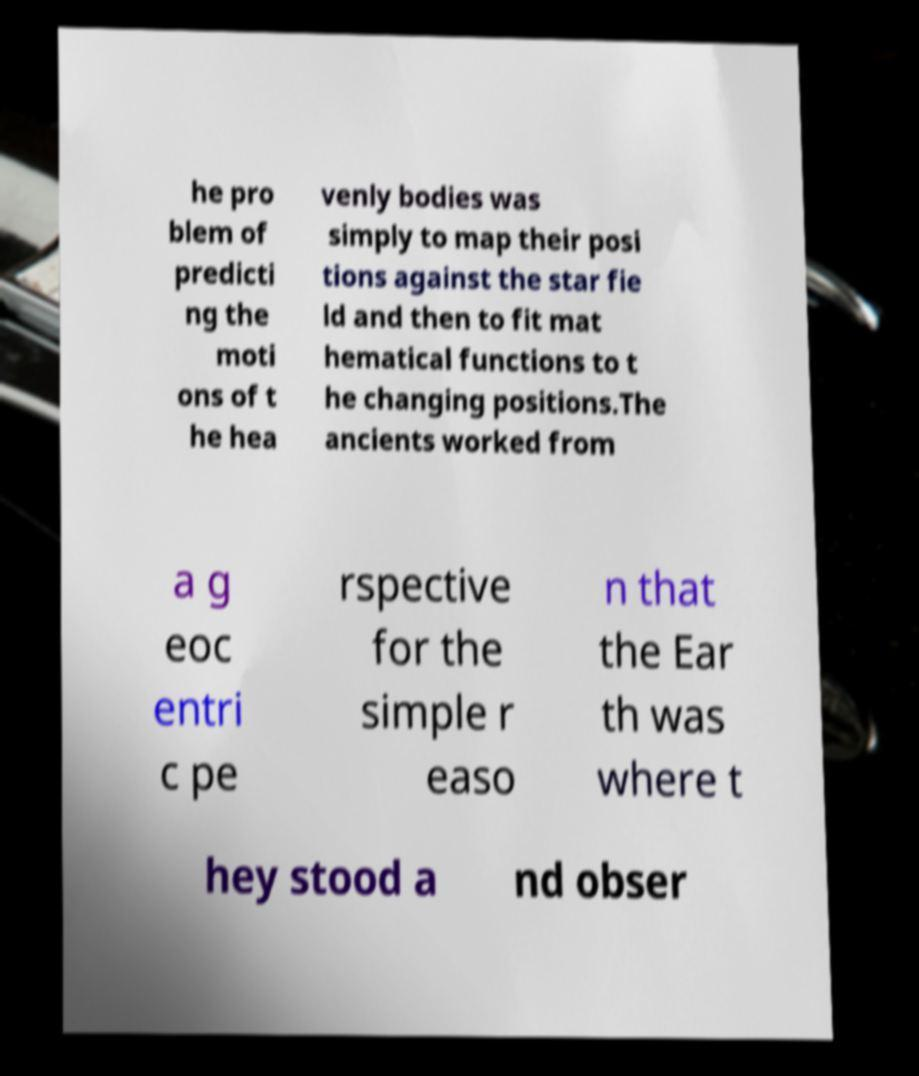Could you extract and type out the text from this image? he pro blem of predicti ng the moti ons of t he hea venly bodies was simply to map their posi tions against the star fie ld and then to fit mat hematical functions to t he changing positions.The ancients worked from a g eoc entri c pe rspective for the simple r easo n that the Ear th was where t hey stood a nd obser 